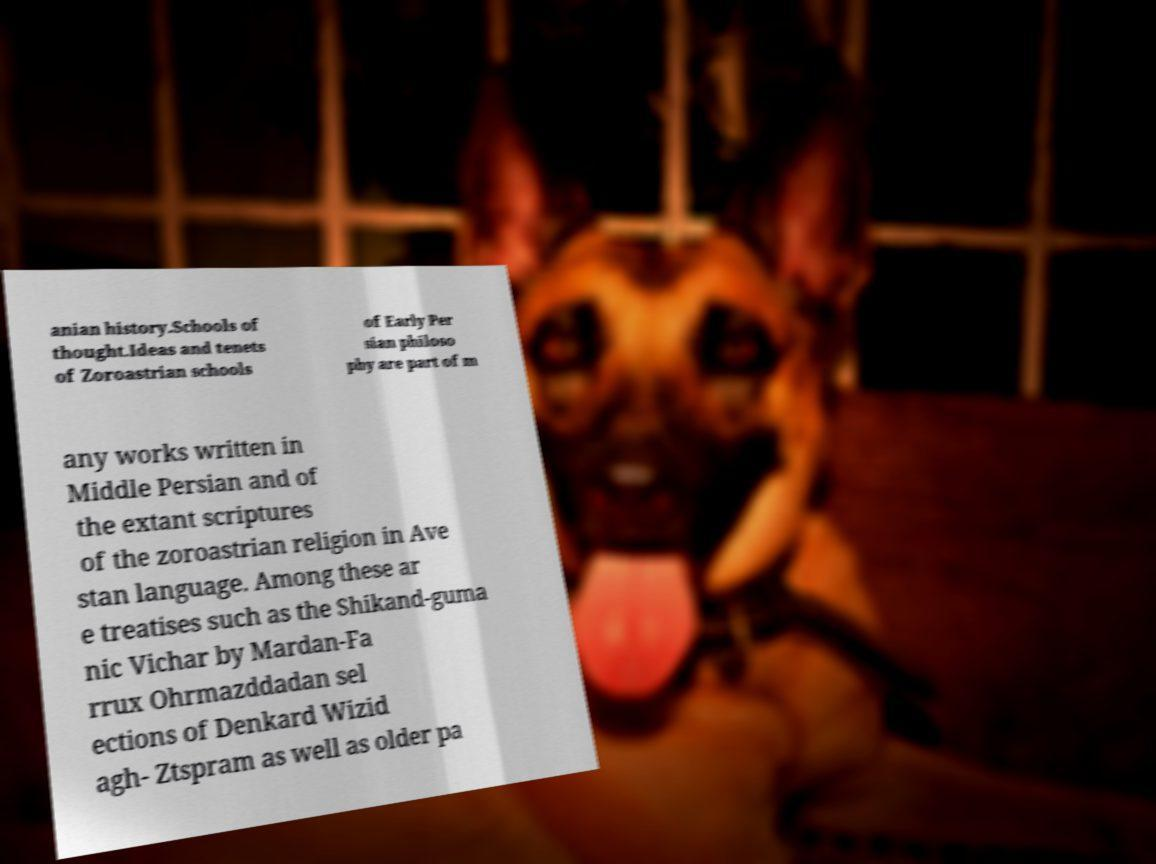Please read and relay the text visible in this image. What does it say? anian history.Schools of thought.Ideas and tenets of Zoroastrian schools of Early Per sian philoso phy are part of m any works written in Middle Persian and of the extant scriptures of the zoroastrian religion in Ave stan language. Among these ar e treatises such as the Shikand-guma nic Vichar by Mardan-Fa rrux Ohrmazddadan sel ections of Denkard Wizid agh- Ztspram as well as older pa 